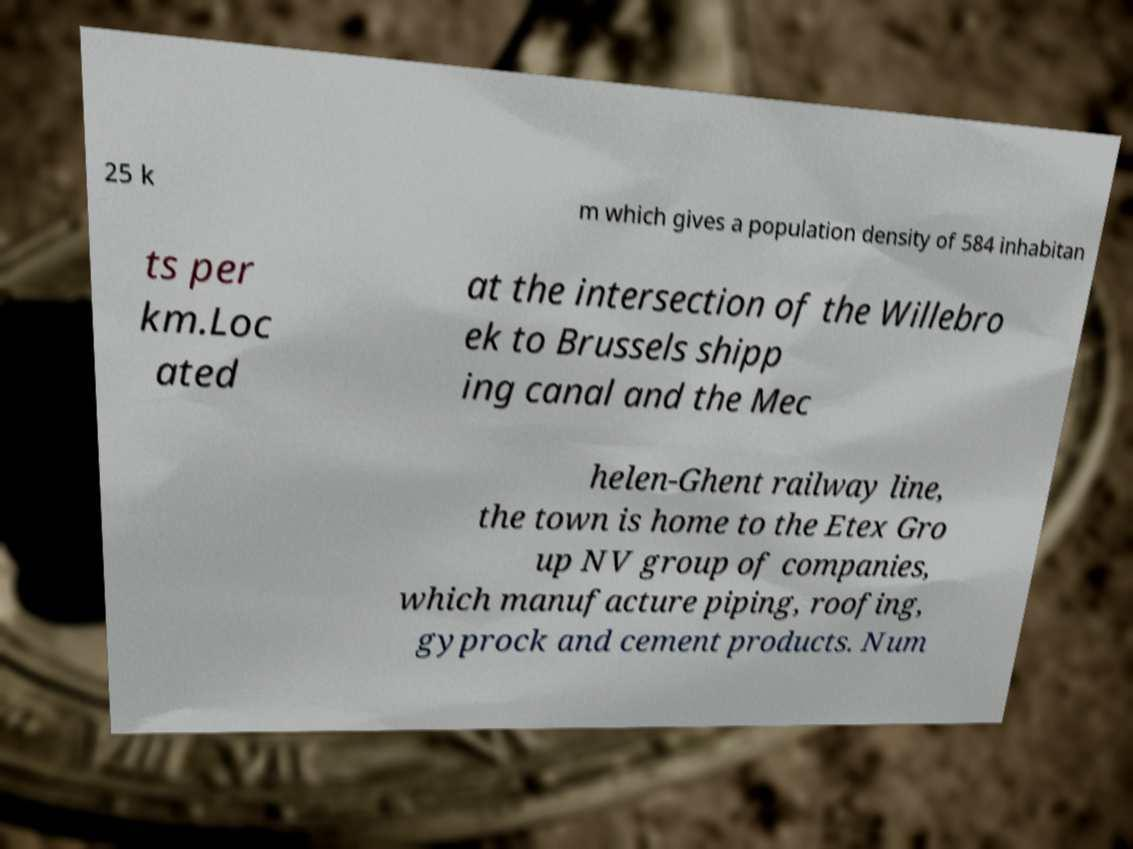For documentation purposes, I need the text within this image transcribed. Could you provide that? 25 k m which gives a population density of 584 inhabitan ts per km.Loc ated at the intersection of the Willebro ek to Brussels shipp ing canal and the Mec helen-Ghent railway line, the town is home to the Etex Gro up NV group of companies, which manufacture piping, roofing, gyprock and cement products. Num 